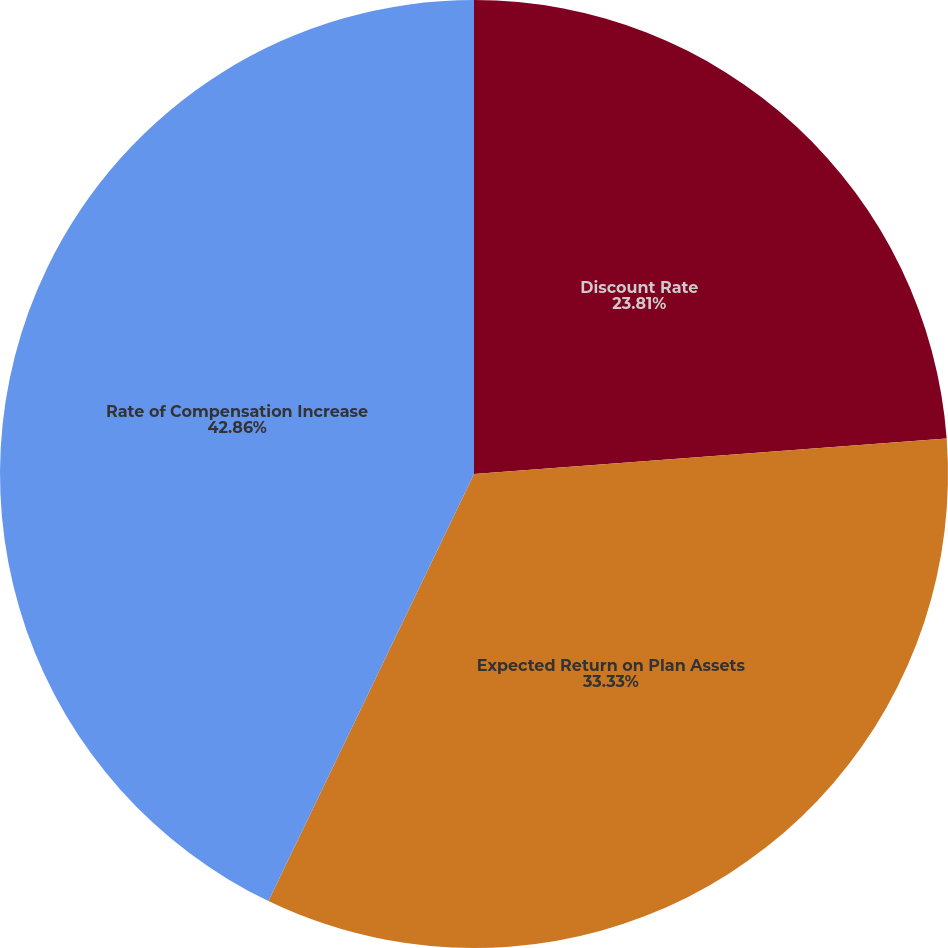Convert chart to OTSL. <chart><loc_0><loc_0><loc_500><loc_500><pie_chart><fcel>Discount Rate<fcel>Expected Return on Plan Assets<fcel>Rate of Compensation Increase<nl><fcel>23.81%<fcel>33.33%<fcel>42.86%<nl></chart> 